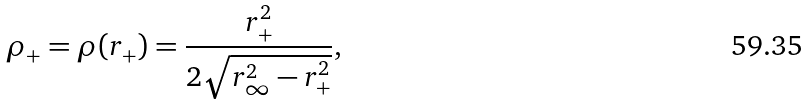Convert formula to latex. <formula><loc_0><loc_0><loc_500><loc_500>\rho _ { + } = \rho { ( r _ { + } ) } = \frac { r _ { + } ^ { 2 } } { 2 \sqrt { r _ { \infty } ^ { 2 } - r _ { + } ^ { 2 } } } ,</formula> 